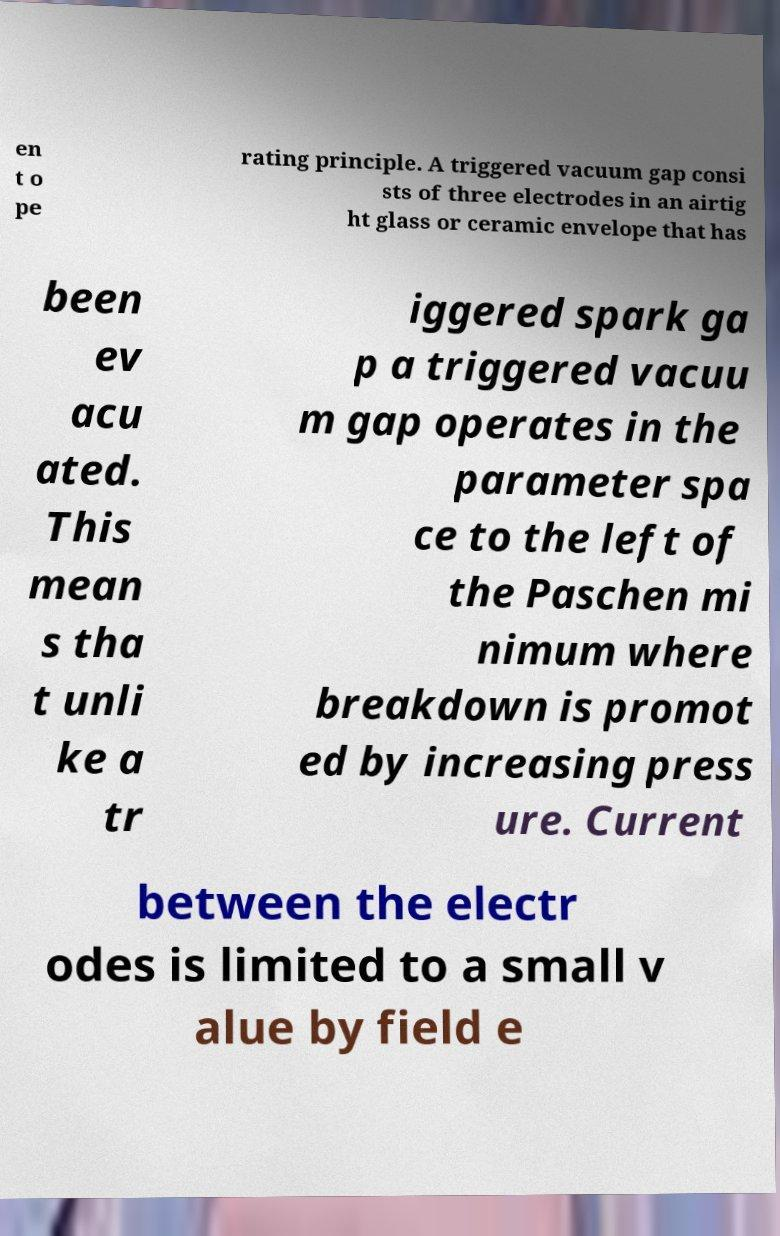Please read and relay the text visible in this image. What does it say? en t o pe rating principle. A triggered vacuum gap consi sts of three electrodes in an airtig ht glass or ceramic envelope that has been ev acu ated. This mean s tha t unli ke a tr iggered spark ga p a triggered vacuu m gap operates in the parameter spa ce to the left of the Paschen mi nimum where breakdown is promot ed by increasing press ure. Current between the electr odes is limited to a small v alue by field e 